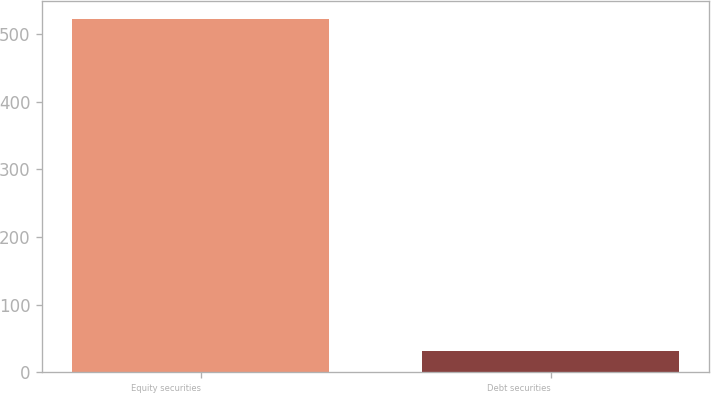<chart> <loc_0><loc_0><loc_500><loc_500><bar_chart><fcel>Equity securities<fcel>Debt securities<nl><fcel>522<fcel>31<nl></chart> 